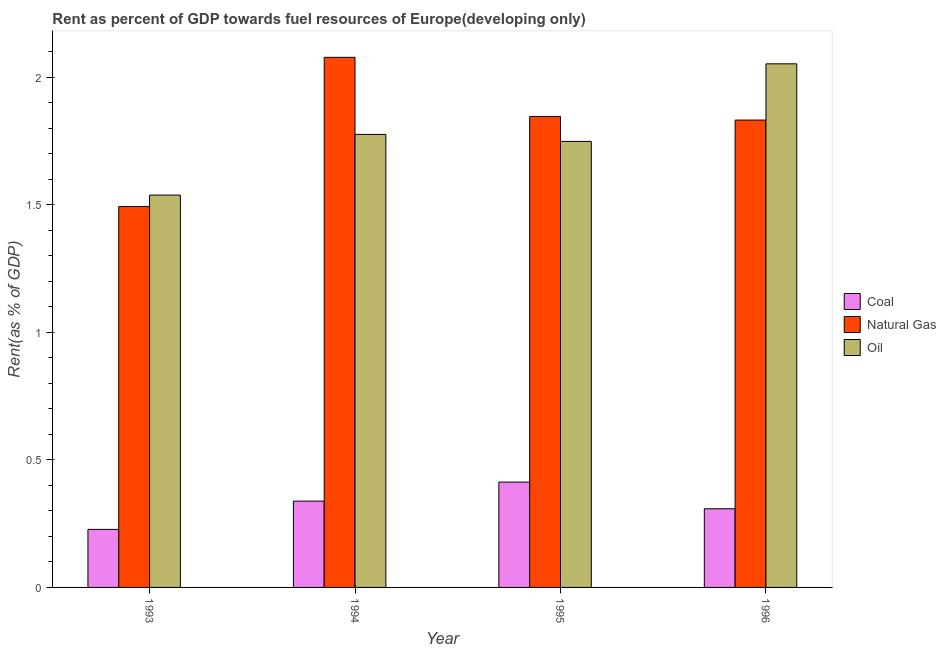How many groups of bars are there?
Keep it short and to the point. 4. Are the number of bars per tick equal to the number of legend labels?
Your response must be concise. Yes. Are the number of bars on each tick of the X-axis equal?
Offer a terse response. Yes. What is the rent towards coal in 1993?
Offer a very short reply. 0.23. Across all years, what is the maximum rent towards oil?
Offer a very short reply. 2.05. Across all years, what is the minimum rent towards natural gas?
Make the answer very short. 1.49. In which year was the rent towards oil maximum?
Provide a short and direct response. 1996. In which year was the rent towards oil minimum?
Your answer should be very brief. 1993. What is the total rent towards oil in the graph?
Keep it short and to the point. 7.12. What is the difference between the rent towards coal in 1993 and that in 1994?
Make the answer very short. -0.11. What is the difference between the rent towards oil in 1996 and the rent towards natural gas in 1994?
Your response must be concise. 0.28. What is the average rent towards oil per year?
Keep it short and to the point. 1.78. In the year 1993, what is the difference between the rent towards coal and rent towards natural gas?
Your answer should be compact. 0. In how many years, is the rent towards oil greater than 0.9 %?
Make the answer very short. 4. What is the ratio of the rent towards natural gas in 1993 to that in 1994?
Offer a very short reply. 0.72. Is the difference between the rent towards coal in 1993 and 1996 greater than the difference between the rent towards oil in 1993 and 1996?
Your answer should be compact. No. What is the difference between the highest and the second highest rent towards oil?
Provide a succinct answer. 0.28. What is the difference between the highest and the lowest rent towards oil?
Make the answer very short. 0.51. In how many years, is the rent towards natural gas greater than the average rent towards natural gas taken over all years?
Give a very brief answer. 3. What does the 3rd bar from the left in 1994 represents?
Your answer should be very brief. Oil. What does the 3rd bar from the right in 1995 represents?
Give a very brief answer. Coal. How many bars are there?
Offer a terse response. 12. Are all the bars in the graph horizontal?
Make the answer very short. No. What is the difference between two consecutive major ticks on the Y-axis?
Your response must be concise. 0.5. Where does the legend appear in the graph?
Ensure brevity in your answer.  Center right. How many legend labels are there?
Offer a very short reply. 3. How are the legend labels stacked?
Your response must be concise. Vertical. What is the title of the graph?
Your answer should be very brief. Rent as percent of GDP towards fuel resources of Europe(developing only). What is the label or title of the Y-axis?
Provide a succinct answer. Rent(as % of GDP). What is the Rent(as % of GDP) of Coal in 1993?
Your response must be concise. 0.23. What is the Rent(as % of GDP) in Natural Gas in 1993?
Your answer should be very brief. 1.49. What is the Rent(as % of GDP) in Oil in 1993?
Keep it short and to the point. 1.54. What is the Rent(as % of GDP) in Coal in 1994?
Keep it short and to the point. 0.34. What is the Rent(as % of GDP) of Natural Gas in 1994?
Offer a terse response. 2.08. What is the Rent(as % of GDP) in Oil in 1994?
Provide a succinct answer. 1.78. What is the Rent(as % of GDP) of Coal in 1995?
Ensure brevity in your answer.  0.41. What is the Rent(as % of GDP) of Natural Gas in 1995?
Ensure brevity in your answer.  1.85. What is the Rent(as % of GDP) of Oil in 1995?
Your response must be concise. 1.75. What is the Rent(as % of GDP) of Coal in 1996?
Offer a terse response. 0.31. What is the Rent(as % of GDP) in Natural Gas in 1996?
Keep it short and to the point. 1.83. What is the Rent(as % of GDP) of Oil in 1996?
Provide a succinct answer. 2.05. Across all years, what is the maximum Rent(as % of GDP) in Coal?
Give a very brief answer. 0.41. Across all years, what is the maximum Rent(as % of GDP) in Natural Gas?
Make the answer very short. 2.08. Across all years, what is the maximum Rent(as % of GDP) in Oil?
Ensure brevity in your answer.  2.05. Across all years, what is the minimum Rent(as % of GDP) in Coal?
Your answer should be very brief. 0.23. Across all years, what is the minimum Rent(as % of GDP) in Natural Gas?
Provide a succinct answer. 1.49. Across all years, what is the minimum Rent(as % of GDP) in Oil?
Keep it short and to the point. 1.54. What is the total Rent(as % of GDP) in Coal in the graph?
Your answer should be compact. 1.29. What is the total Rent(as % of GDP) of Natural Gas in the graph?
Make the answer very short. 7.25. What is the total Rent(as % of GDP) of Oil in the graph?
Give a very brief answer. 7.12. What is the difference between the Rent(as % of GDP) in Coal in 1993 and that in 1994?
Ensure brevity in your answer.  -0.11. What is the difference between the Rent(as % of GDP) in Natural Gas in 1993 and that in 1994?
Provide a succinct answer. -0.59. What is the difference between the Rent(as % of GDP) in Oil in 1993 and that in 1994?
Give a very brief answer. -0.24. What is the difference between the Rent(as % of GDP) of Coal in 1993 and that in 1995?
Make the answer very short. -0.19. What is the difference between the Rent(as % of GDP) of Natural Gas in 1993 and that in 1995?
Ensure brevity in your answer.  -0.35. What is the difference between the Rent(as % of GDP) in Oil in 1993 and that in 1995?
Ensure brevity in your answer.  -0.21. What is the difference between the Rent(as % of GDP) of Coal in 1993 and that in 1996?
Provide a succinct answer. -0.08. What is the difference between the Rent(as % of GDP) of Natural Gas in 1993 and that in 1996?
Ensure brevity in your answer.  -0.34. What is the difference between the Rent(as % of GDP) of Oil in 1993 and that in 1996?
Your response must be concise. -0.51. What is the difference between the Rent(as % of GDP) of Coal in 1994 and that in 1995?
Your response must be concise. -0.07. What is the difference between the Rent(as % of GDP) of Natural Gas in 1994 and that in 1995?
Give a very brief answer. 0.23. What is the difference between the Rent(as % of GDP) of Oil in 1994 and that in 1995?
Offer a terse response. 0.03. What is the difference between the Rent(as % of GDP) in Natural Gas in 1994 and that in 1996?
Make the answer very short. 0.25. What is the difference between the Rent(as % of GDP) of Oil in 1994 and that in 1996?
Offer a very short reply. -0.28. What is the difference between the Rent(as % of GDP) of Coal in 1995 and that in 1996?
Your answer should be very brief. 0.1. What is the difference between the Rent(as % of GDP) in Natural Gas in 1995 and that in 1996?
Offer a very short reply. 0.01. What is the difference between the Rent(as % of GDP) in Oil in 1995 and that in 1996?
Your response must be concise. -0.3. What is the difference between the Rent(as % of GDP) in Coal in 1993 and the Rent(as % of GDP) in Natural Gas in 1994?
Provide a short and direct response. -1.85. What is the difference between the Rent(as % of GDP) in Coal in 1993 and the Rent(as % of GDP) in Oil in 1994?
Your answer should be very brief. -1.55. What is the difference between the Rent(as % of GDP) in Natural Gas in 1993 and the Rent(as % of GDP) in Oil in 1994?
Keep it short and to the point. -0.28. What is the difference between the Rent(as % of GDP) of Coal in 1993 and the Rent(as % of GDP) of Natural Gas in 1995?
Keep it short and to the point. -1.62. What is the difference between the Rent(as % of GDP) of Coal in 1993 and the Rent(as % of GDP) of Oil in 1995?
Your answer should be very brief. -1.52. What is the difference between the Rent(as % of GDP) in Natural Gas in 1993 and the Rent(as % of GDP) in Oil in 1995?
Provide a succinct answer. -0.26. What is the difference between the Rent(as % of GDP) in Coal in 1993 and the Rent(as % of GDP) in Natural Gas in 1996?
Your response must be concise. -1.6. What is the difference between the Rent(as % of GDP) of Coal in 1993 and the Rent(as % of GDP) of Oil in 1996?
Offer a very short reply. -1.83. What is the difference between the Rent(as % of GDP) in Natural Gas in 1993 and the Rent(as % of GDP) in Oil in 1996?
Your answer should be very brief. -0.56. What is the difference between the Rent(as % of GDP) of Coal in 1994 and the Rent(as % of GDP) of Natural Gas in 1995?
Keep it short and to the point. -1.51. What is the difference between the Rent(as % of GDP) in Coal in 1994 and the Rent(as % of GDP) in Oil in 1995?
Provide a short and direct response. -1.41. What is the difference between the Rent(as % of GDP) of Natural Gas in 1994 and the Rent(as % of GDP) of Oil in 1995?
Ensure brevity in your answer.  0.33. What is the difference between the Rent(as % of GDP) of Coal in 1994 and the Rent(as % of GDP) of Natural Gas in 1996?
Your answer should be compact. -1.49. What is the difference between the Rent(as % of GDP) in Coal in 1994 and the Rent(as % of GDP) in Oil in 1996?
Your response must be concise. -1.71. What is the difference between the Rent(as % of GDP) of Natural Gas in 1994 and the Rent(as % of GDP) of Oil in 1996?
Your answer should be very brief. 0.03. What is the difference between the Rent(as % of GDP) of Coal in 1995 and the Rent(as % of GDP) of Natural Gas in 1996?
Keep it short and to the point. -1.42. What is the difference between the Rent(as % of GDP) in Coal in 1995 and the Rent(as % of GDP) in Oil in 1996?
Your answer should be compact. -1.64. What is the difference between the Rent(as % of GDP) in Natural Gas in 1995 and the Rent(as % of GDP) in Oil in 1996?
Provide a short and direct response. -0.21. What is the average Rent(as % of GDP) in Coal per year?
Offer a very short reply. 0.32. What is the average Rent(as % of GDP) in Natural Gas per year?
Your answer should be very brief. 1.81. What is the average Rent(as % of GDP) of Oil per year?
Provide a short and direct response. 1.78. In the year 1993, what is the difference between the Rent(as % of GDP) of Coal and Rent(as % of GDP) of Natural Gas?
Your answer should be very brief. -1.27. In the year 1993, what is the difference between the Rent(as % of GDP) in Coal and Rent(as % of GDP) in Oil?
Your answer should be compact. -1.31. In the year 1993, what is the difference between the Rent(as % of GDP) in Natural Gas and Rent(as % of GDP) in Oil?
Ensure brevity in your answer.  -0.05. In the year 1994, what is the difference between the Rent(as % of GDP) of Coal and Rent(as % of GDP) of Natural Gas?
Offer a very short reply. -1.74. In the year 1994, what is the difference between the Rent(as % of GDP) in Coal and Rent(as % of GDP) in Oil?
Keep it short and to the point. -1.44. In the year 1994, what is the difference between the Rent(as % of GDP) in Natural Gas and Rent(as % of GDP) in Oil?
Provide a succinct answer. 0.3. In the year 1995, what is the difference between the Rent(as % of GDP) of Coal and Rent(as % of GDP) of Natural Gas?
Your answer should be compact. -1.43. In the year 1995, what is the difference between the Rent(as % of GDP) of Coal and Rent(as % of GDP) of Oil?
Make the answer very short. -1.34. In the year 1995, what is the difference between the Rent(as % of GDP) in Natural Gas and Rent(as % of GDP) in Oil?
Provide a succinct answer. 0.1. In the year 1996, what is the difference between the Rent(as % of GDP) of Coal and Rent(as % of GDP) of Natural Gas?
Offer a terse response. -1.52. In the year 1996, what is the difference between the Rent(as % of GDP) of Coal and Rent(as % of GDP) of Oil?
Your answer should be compact. -1.74. In the year 1996, what is the difference between the Rent(as % of GDP) in Natural Gas and Rent(as % of GDP) in Oil?
Your answer should be very brief. -0.22. What is the ratio of the Rent(as % of GDP) of Coal in 1993 to that in 1994?
Provide a short and direct response. 0.67. What is the ratio of the Rent(as % of GDP) in Natural Gas in 1993 to that in 1994?
Your response must be concise. 0.72. What is the ratio of the Rent(as % of GDP) of Oil in 1993 to that in 1994?
Keep it short and to the point. 0.87. What is the ratio of the Rent(as % of GDP) of Coal in 1993 to that in 1995?
Provide a succinct answer. 0.55. What is the ratio of the Rent(as % of GDP) in Natural Gas in 1993 to that in 1995?
Make the answer very short. 0.81. What is the ratio of the Rent(as % of GDP) of Oil in 1993 to that in 1995?
Your answer should be compact. 0.88. What is the ratio of the Rent(as % of GDP) in Coal in 1993 to that in 1996?
Provide a short and direct response. 0.74. What is the ratio of the Rent(as % of GDP) in Natural Gas in 1993 to that in 1996?
Provide a short and direct response. 0.81. What is the ratio of the Rent(as % of GDP) in Oil in 1993 to that in 1996?
Offer a terse response. 0.75. What is the ratio of the Rent(as % of GDP) in Coal in 1994 to that in 1995?
Provide a short and direct response. 0.82. What is the ratio of the Rent(as % of GDP) in Natural Gas in 1994 to that in 1995?
Provide a short and direct response. 1.13. What is the ratio of the Rent(as % of GDP) of Oil in 1994 to that in 1995?
Your answer should be very brief. 1.02. What is the ratio of the Rent(as % of GDP) in Coal in 1994 to that in 1996?
Give a very brief answer. 1.1. What is the ratio of the Rent(as % of GDP) in Natural Gas in 1994 to that in 1996?
Give a very brief answer. 1.13. What is the ratio of the Rent(as % of GDP) of Oil in 1994 to that in 1996?
Offer a terse response. 0.87. What is the ratio of the Rent(as % of GDP) in Coal in 1995 to that in 1996?
Make the answer very short. 1.34. What is the ratio of the Rent(as % of GDP) of Natural Gas in 1995 to that in 1996?
Keep it short and to the point. 1.01. What is the ratio of the Rent(as % of GDP) in Oil in 1995 to that in 1996?
Offer a terse response. 0.85. What is the difference between the highest and the second highest Rent(as % of GDP) in Coal?
Offer a very short reply. 0.07. What is the difference between the highest and the second highest Rent(as % of GDP) of Natural Gas?
Keep it short and to the point. 0.23. What is the difference between the highest and the second highest Rent(as % of GDP) of Oil?
Provide a succinct answer. 0.28. What is the difference between the highest and the lowest Rent(as % of GDP) of Coal?
Provide a short and direct response. 0.19. What is the difference between the highest and the lowest Rent(as % of GDP) of Natural Gas?
Your answer should be compact. 0.59. What is the difference between the highest and the lowest Rent(as % of GDP) of Oil?
Keep it short and to the point. 0.51. 